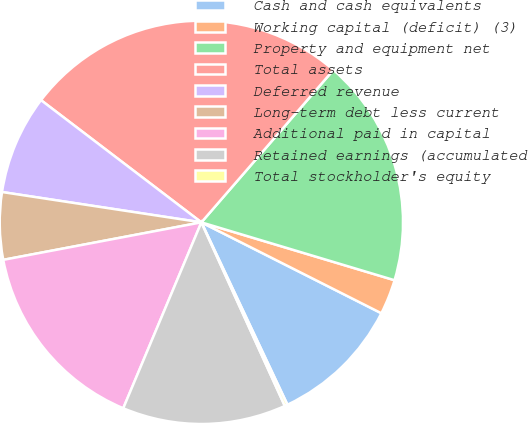<chart> <loc_0><loc_0><loc_500><loc_500><pie_chart><fcel>Cash and cash equivalents<fcel>Working capital (deficit) (3)<fcel>Property and equipment net<fcel>Total assets<fcel>Deferred revenue<fcel>Long-term debt less current<fcel>Additional paid in capital<fcel>Retained earnings (accumulated<fcel>Total stockholder's equity<nl><fcel>10.54%<fcel>2.81%<fcel>18.27%<fcel>26.0%<fcel>7.96%<fcel>5.38%<fcel>15.69%<fcel>13.12%<fcel>0.23%<nl></chart> 